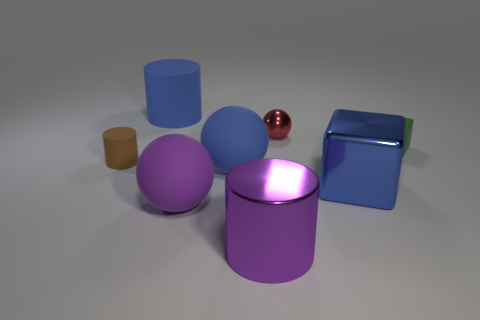What number of metal things are large cylinders or purple balls?
Your answer should be very brief. 1. The big object that is both on the left side of the large blue rubber ball and behind the big blue metal block is made of what material?
Give a very brief answer. Rubber. Are the green thing and the tiny cylinder made of the same material?
Make the answer very short. Yes. What is the size of the ball that is both to the left of the purple cylinder and behind the big blue shiny cube?
Ensure brevity in your answer.  Large. The brown rubber object is what shape?
Provide a short and direct response. Cylinder. How many things are either big spheres or blue matte cylinders to the left of the red ball?
Keep it short and to the point. 3. There is a tiny matte thing behind the small brown object; does it have the same color as the metallic cylinder?
Keep it short and to the point. No. The tiny object that is behind the tiny brown thing and left of the blue metal block is what color?
Your response must be concise. Red. What is the material of the cylinder behind the rubber block?
Offer a terse response. Rubber. The matte cube has what size?
Offer a terse response. Small. 